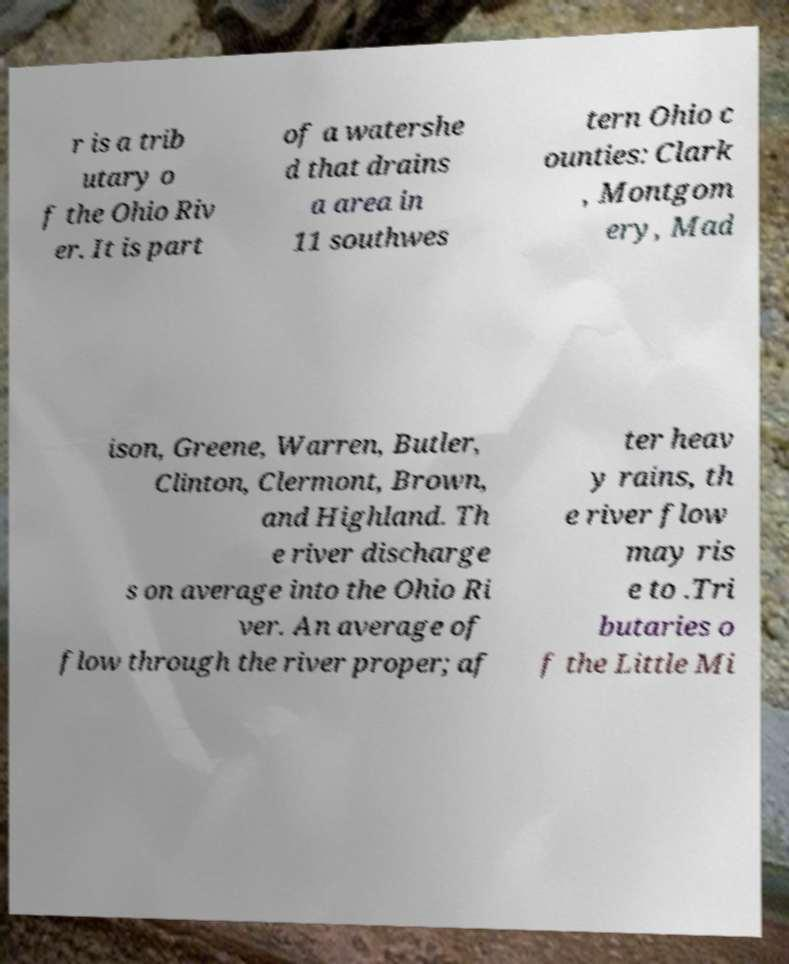Please read and relay the text visible in this image. What does it say? r is a trib utary o f the Ohio Riv er. It is part of a watershe d that drains a area in 11 southwes tern Ohio c ounties: Clark , Montgom ery, Mad ison, Greene, Warren, Butler, Clinton, Clermont, Brown, and Highland. Th e river discharge s on average into the Ohio Ri ver. An average of flow through the river proper; af ter heav y rains, th e river flow may ris e to .Tri butaries o f the Little Mi 